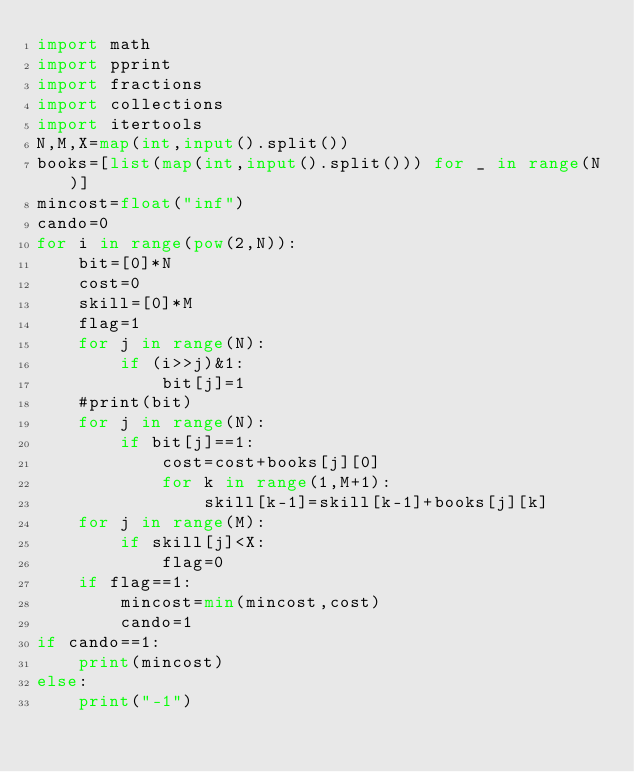Convert code to text. <code><loc_0><loc_0><loc_500><loc_500><_Python_>import math
import pprint
import fractions
import collections
import itertools
N,M,X=map(int,input().split())
books=[list(map(int,input().split())) for _ in range(N)]
mincost=float("inf")
cando=0
for i in range(pow(2,N)):
    bit=[0]*N
    cost=0
    skill=[0]*M
    flag=1
    for j in range(N):
        if (i>>j)&1:
            bit[j]=1
    #print(bit)
    for j in range(N):
        if bit[j]==1:
            cost=cost+books[j][0]
            for k in range(1,M+1):
                skill[k-1]=skill[k-1]+books[j][k]
    for j in range(M):
        if skill[j]<X:
            flag=0
    if flag==1:
        mincost=min(mincost,cost)
        cando=1
if cando==1:
    print(mincost)
else:
    print("-1")</code> 